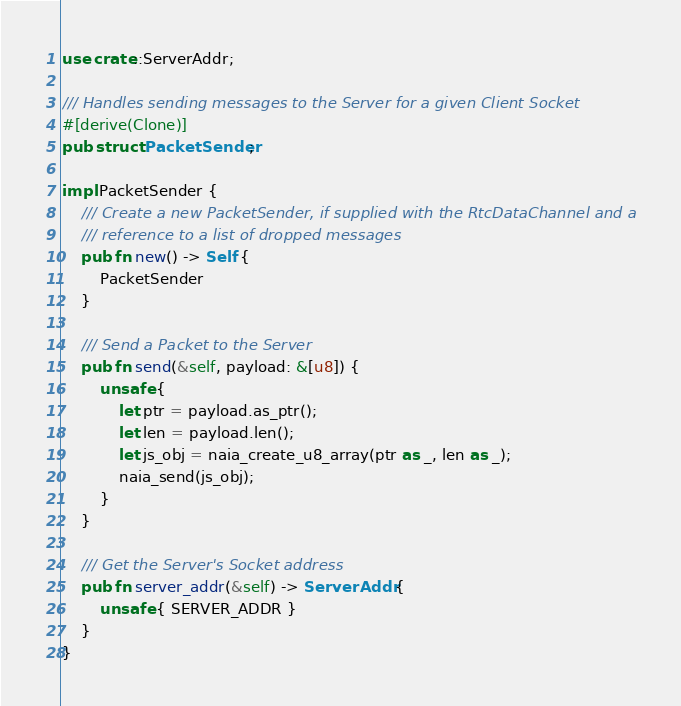Convert code to text. <code><loc_0><loc_0><loc_500><loc_500><_Rust_>use crate::ServerAddr;

/// Handles sending messages to the Server for a given Client Socket
#[derive(Clone)]
pub struct PacketSender;

impl PacketSender {
    /// Create a new PacketSender, if supplied with the RtcDataChannel and a
    /// reference to a list of dropped messages
    pub fn new() -> Self {
        PacketSender
    }

    /// Send a Packet to the Server
    pub fn send(&self, payload: &[u8]) {
        unsafe {
            let ptr = payload.as_ptr();
            let len = payload.len();
            let js_obj = naia_create_u8_array(ptr as _, len as _);
            naia_send(js_obj);
        }
    }

    /// Get the Server's Socket address
    pub fn server_addr(&self) -> ServerAddr {
        unsafe { SERVER_ADDR }
    }
}
</code> 